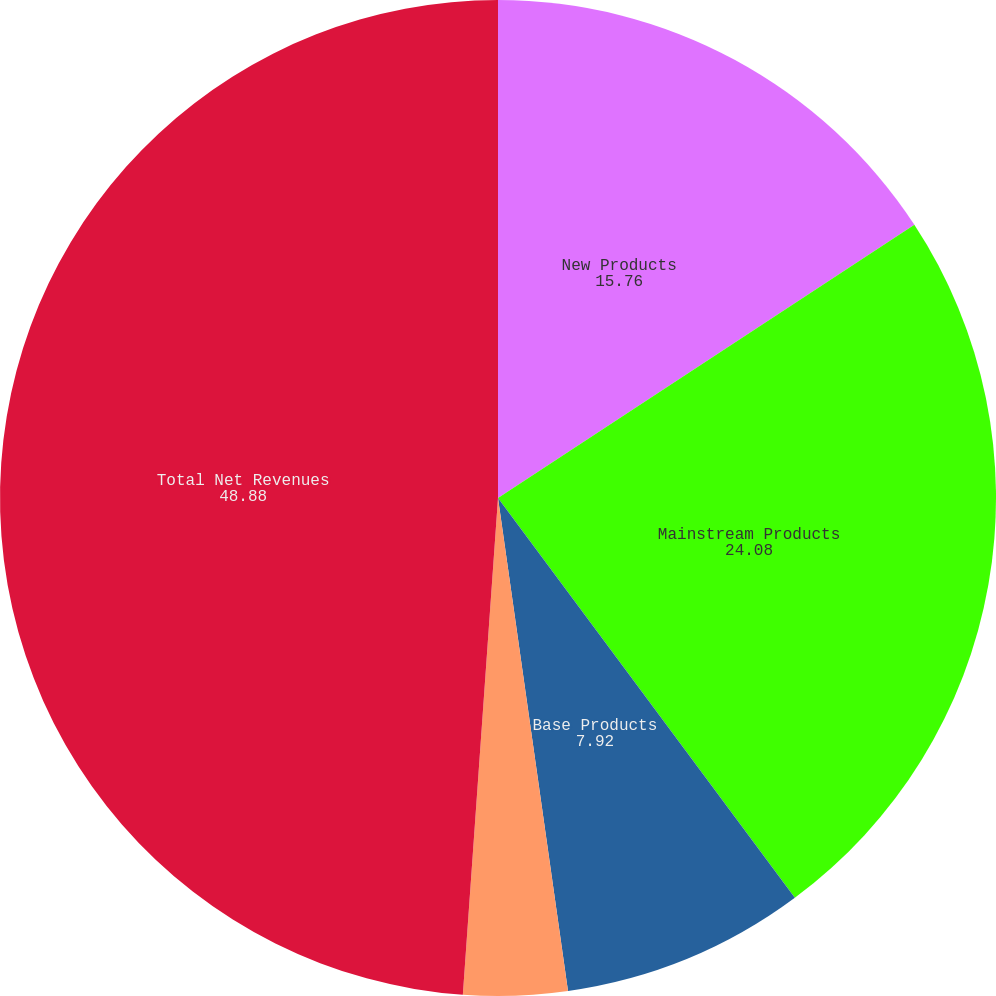Convert chart. <chart><loc_0><loc_0><loc_500><loc_500><pie_chart><fcel>New Products<fcel>Mainstream Products<fcel>Base Products<fcel>Support Products<fcel>Total Net Revenues<nl><fcel>15.76%<fcel>24.08%<fcel>7.92%<fcel>3.37%<fcel>48.88%<nl></chart> 